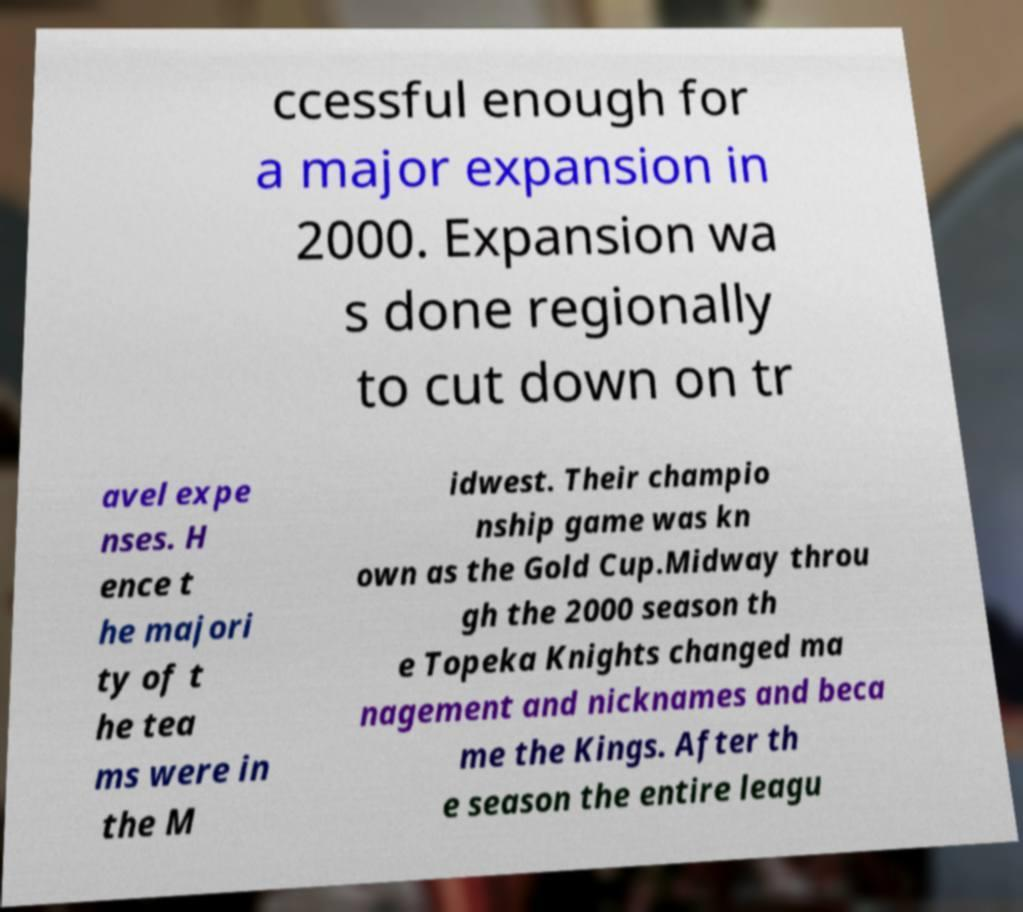For documentation purposes, I need the text within this image transcribed. Could you provide that? ccessful enough for a major expansion in 2000. Expansion wa s done regionally to cut down on tr avel expe nses. H ence t he majori ty of t he tea ms were in the M idwest. Their champio nship game was kn own as the Gold Cup.Midway throu gh the 2000 season th e Topeka Knights changed ma nagement and nicknames and beca me the Kings. After th e season the entire leagu 